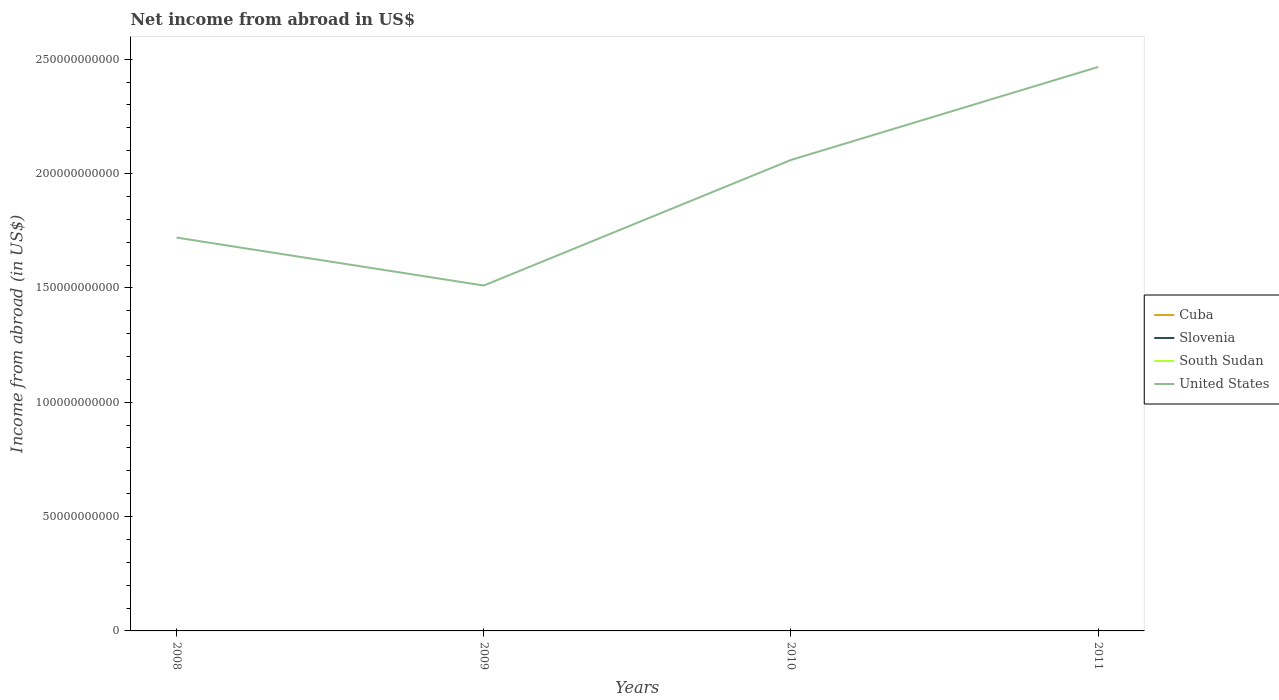How many different coloured lines are there?
Keep it short and to the point. 1. Is the number of lines equal to the number of legend labels?
Provide a short and direct response. No. Across all years, what is the maximum net income from abroad in United States?
Keep it short and to the point. 1.51e+11. What is the total net income from abroad in United States in the graph?
Make the answer very short. -4.07e+1. What is the difference between the highest and the lowest net income from abroad in South Sudan?
Keep it short and to the point. 0. Is the net income from abroad in Cuba strictly greater than the net income from abroad in United States over the years?
Keep it short and to the point. Yes. How many years are there in the graph?
Offer a terse response. 4. What is the difference between two consecutive major ticks on the Y-axis?
Provide a short and direct response. 5.00e+1. What is the title of the graph?
Provide a succinct answer. Net income from abroad in US$. What is the label or title of the Y-axis?
Ensure brevity in your answer.  Income from abroad (in US$). What is the Income from abroad (in US$) of Cuba in 2008?
Offer a very short reply. 0. What is the Income from abroad (in US$) of United States in 2008?
Keep it short and to the point. 1.72e+11. What is the Income from abroad (in US$) in Slovenia in 2009?
Keep it short and to the point. 0. What is the Income from abroad (in US$) in United States in 2009?
Your answer should be very brief. 1.51e+11. What is the Income from abroad (in US$) of Cuba in 2010?
Make the answer very short. 0. What is the Income from abroad (in US$) of Slovenia in 2010?
Your answer should be compact. 0. What is the Income from abroad (in US$) in South Sudan in 2010?
Provide a short and direct response. 0. What is the Income from abroad (in US$) of United States in 2010?
Your answer should be compact. 2.06e+11. What is the Income from abroad (in US$) in Cuba in 2011?
Your answer should be compact. 0. What is the Income from abroad (in US$) of South Sudan in 2011?
Offer a terse response. 0. What is the Income from abroad (in US$) in United States in 2011?
Provide a short and direct response. 2.47e+11. Across all years, what is the maximum Income from abroad (in US$) in United States?
Offer a terse response. 2.47e+11. Across all years, what is the minimum Income from abroad (in US$) of United States?
Offer a very short reply. 1.51e+11. What is the total Income from abroad (in US$) in Slovenia in the graph?
Your response must be concise. 0. What is the total Income from abroad (in US$) of United States in the graph?
Your answer should be compact. 7.76e+11. What is the difference between the Income from abroad (in US$) of United States in 2008 and that in 2009?
Offer a very short reply. 2.10e+1. What is the difference between the Income from abroad (in US$) of United States in 2008 and that in 2010?
Offer a terse response. -3.40e+1. What is the difference between the Income from abroad (in US$) in United States in 2008 and that in 2011?
Your response must be concise. -7.46e+1. What is the difference between the Income from abroad (in US$) of United States in 2009 and that in 2010?
Offer a terse response. -5.49e+1. What is the difference between the Income from abroad (in US$) of United States in 2009 and that in 2011?
Your answer should be very brief. -9.56e+1. What is the difference between the Income from abroad (in US$) in United States in 2010 and that in 2011?
Your answer should be compact. -4.07e+1. What is the average Income from abroad (in US$) in Cuba per year?
Ensure brevity in your answer.  0. What is the average Income from abroad (in US$) in South Sudan per year?
Your response must be concise. 0. What is the average Income from abroad (in US$) in United States per year?
Offer a terse response. 1.94e+11. What is the ratio of the Income from abroad (in US$) of United States in 2008 to that in 2009?
Your answer should be very brief. 1.14. What is the ratio of the Income from abroad (in US$) of United States in 2008 to that in 2010?
Your answer should be compact. 0.84. What is the ratio of the Income from abroad (in US$) in United States in 2008 to that in 2011?
Make the answer very short. 0.7. What is the ratio of the Income from abroad (in US$) in United States in 2009 to that in 2010?
Offer a very short reply. 0.73. What is the ratio of the Income from abroad (in US$) in United States in 2009 to that in 2011?
Your answer should be very brief. 0.61. What is the ratio of the Income from abroad (in US$) of United States in 2010 to that in 2011?
Keep it short and to the point. 0.84. What is the difference between the highest and the second highest Income from abroad (in US$) of United States?
Offer a very short reply. 4.07e+1. What is the difference between the highest and the lowest Income from abroad (in US$) in United States?
Your answer should be compact. 9.56e+1. 